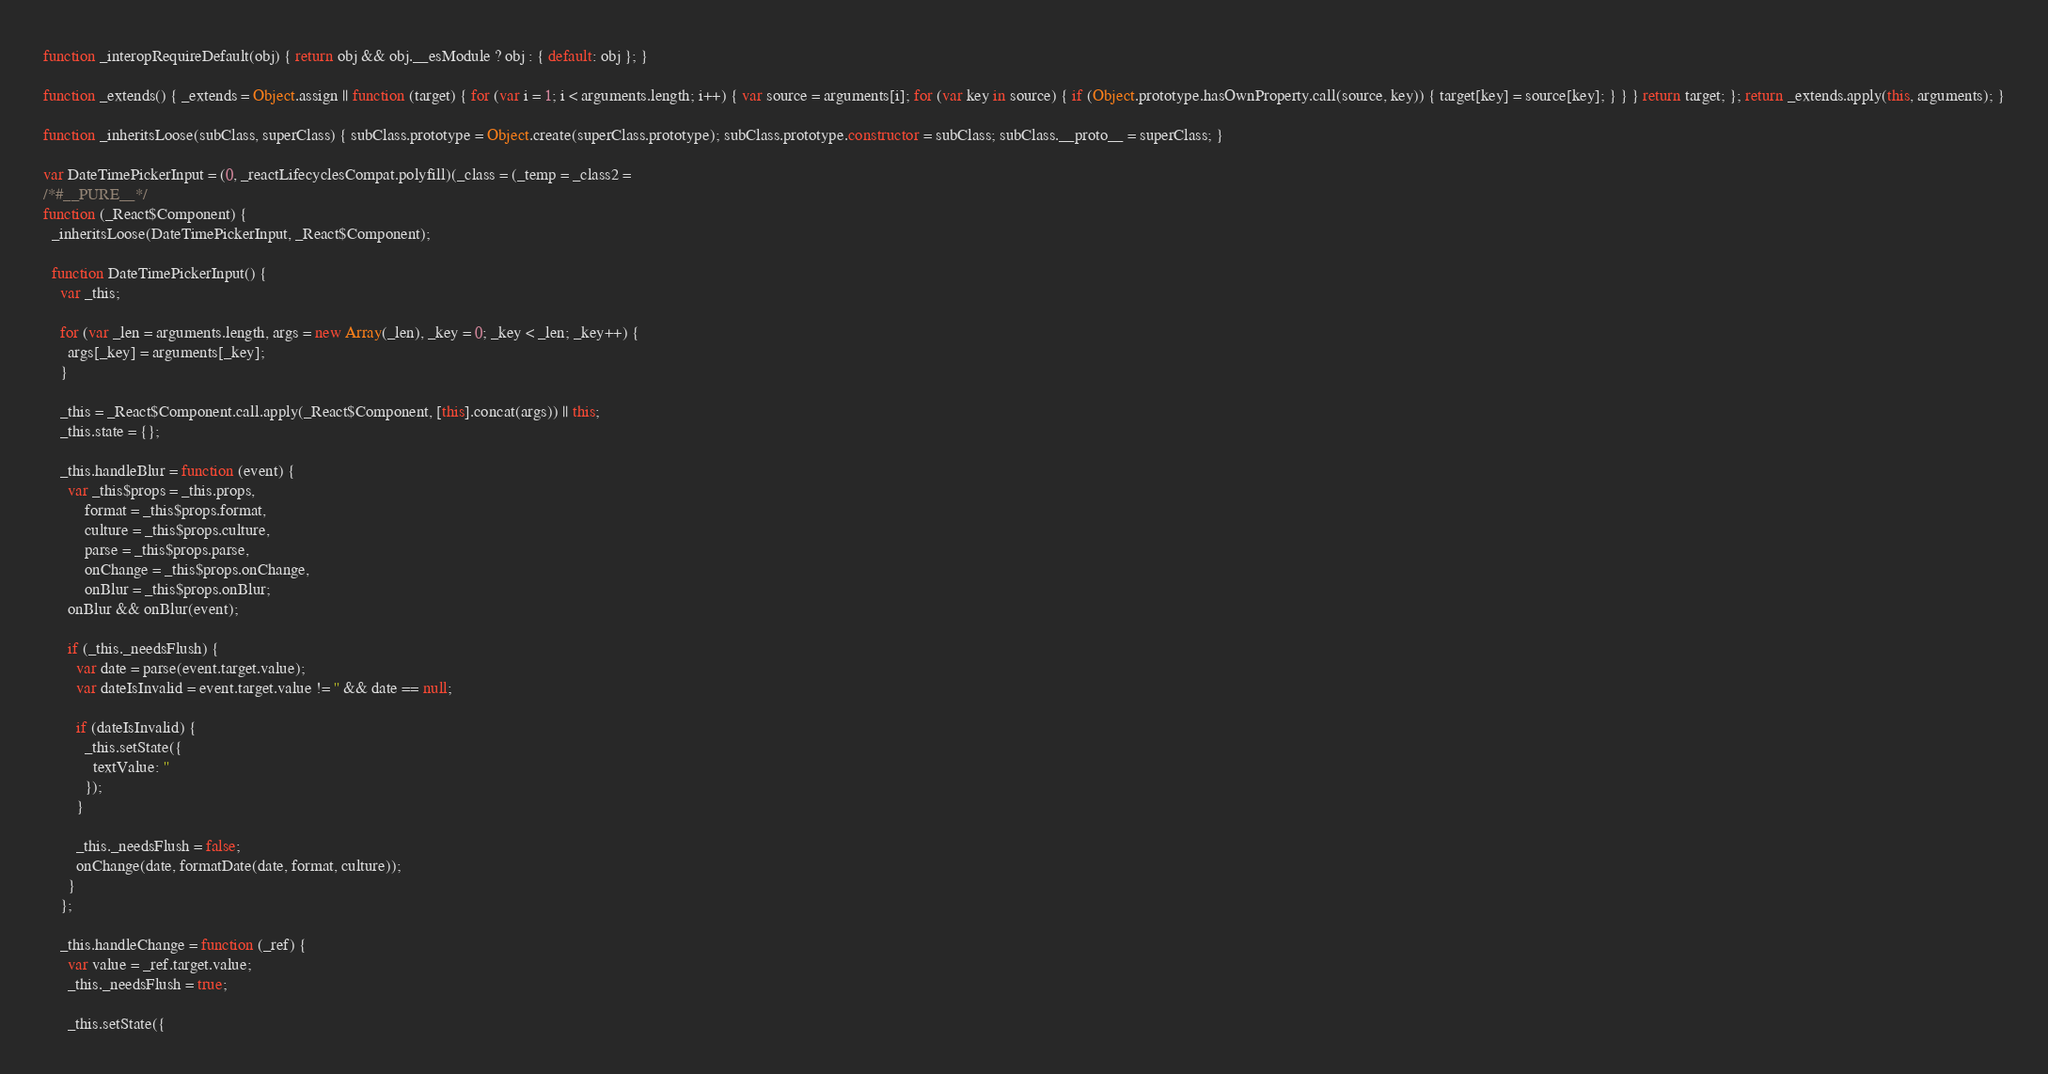<code> <loc_0><loc_0><loc_500><loc_500><_JavaScript_>
function _interopRequireDefault(obj) { return obj && obj.__esModule ? obj : { default: obj }; }

function _extends() { _extends = Object.assign || function (target) { for (var i = 1; i < arguments.length; i++) { var source = arguments[i]; for (var key in source) { if (Object.prototype.hasOwnProperty.call(source, key)) { target[key] = source[key]; } } } return target; }; return _extends.apply(this, arguments); }

function _inheritsLoose(subClass, superClass) { subClass.prototype = Object.create(superClass.prototype); subClass.prototype.constructor = subClass; subClass.__proto__ = superClass; }

var DateTimePickerInput = (0, _reactLifecyclesCompat.polyfill)(_class = (_temp = _class2 =
/*#__PURE__*/
function (_React$Component) {
  _inheritsLoose(DateTimePickerInput, _React$Component);

  function DateTimePickerInput() {
    var _this;

    for (var _len = arguments.length, args = new Array(_len), _key = 0; _key < _len; _key++) {
      args[_key] = arguments[_key];
    }

    _this = _React$Component.call.apply(_React$Component, [this].concat(args)) || this;
    _this.state = {};

    _this.handleBlur = function (event) {
      var _this$props = _this.props,
          format = _this$props.format,
          culture = _this$props.culture,
          parse = _this$props.parse,
          onChange = _this$props.onChange,
          onBlur = _this$props.onBlur;
      onBlur && onBlur(event);

      if (_this._needsFlush) {
        var date = parse(event.target.value);
        var dateIsInvalid = event.target.value != '' && date == null;

        if (dateIsInvalid) {
          _this.setState({
            textValue: ''
          });
        }

        _this._needsFlush = false;
        onChange(date, formatDate(date, format, culture));
      }
    };

    _this.handleChange = function (_ref) {
      var value = _ref.target.value;
      _this._needsFlush = true;

      _this.setState({</code> 